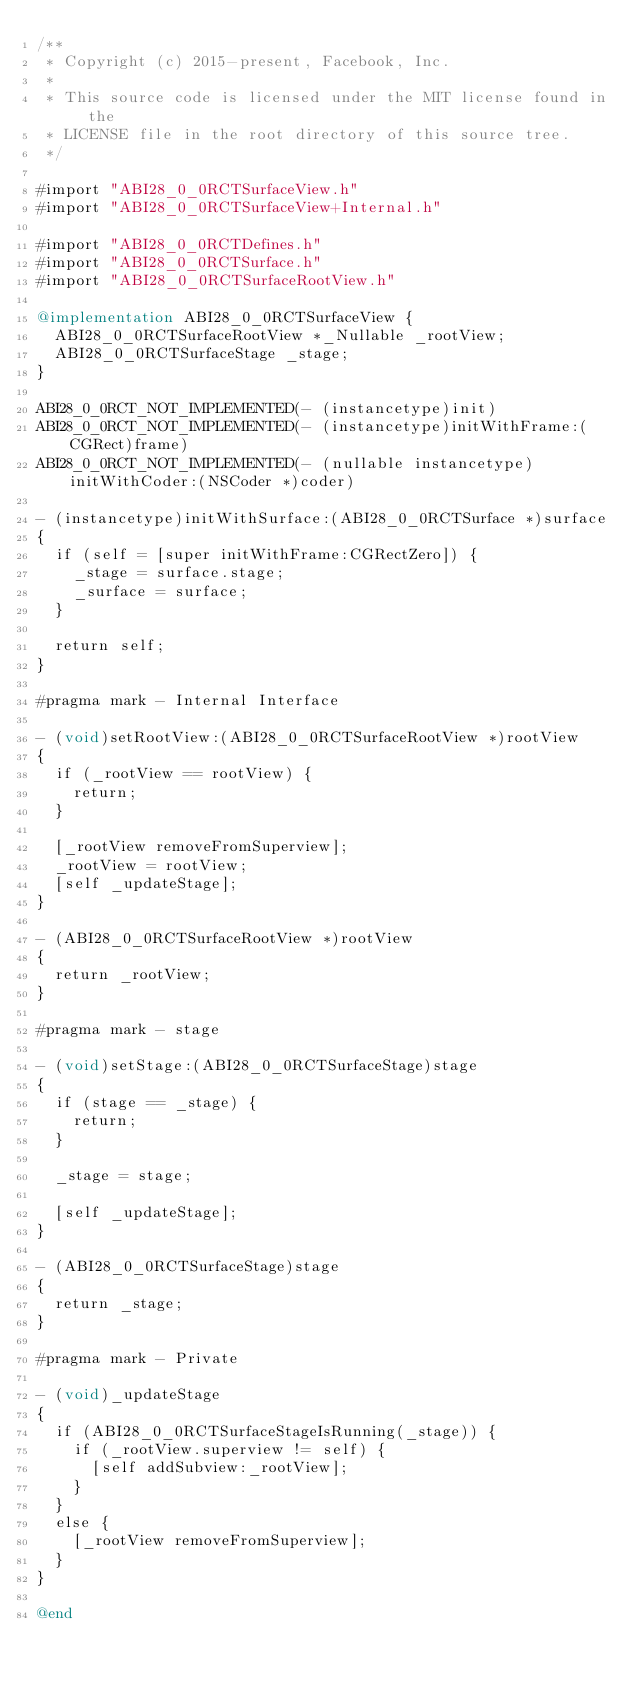Convert code to text. <code><loc_0><loc_0><loc_500><loc_500><_ObjectiveC_>/**
 * Copyright (c) 2015-present, Facebook, Inc.
 *
 * This source code is licensed under the MIT license found in the
 * LICENSE file in the root directory of this source tree.
 */

#import "ABI28_0_0RCTSurfaceView.h"
#import "ABI28_0_0RCTSurfaceView+Internal.h"

#import "ABI28_0_0RCTDefines.h"
#import "ABI28_0_0RCTSurface.h"
#import "ABI28_0_0RCTSurfaceRootView.h"

@implementation ABI28_0_0RCTSurfaceView {
  ABI28_0_0RCTSurfaceRootView *_Nullable _rootView;
  ABI28_0_0RCTSurfaceStage _stage;
}

ABI28_0_0RCT_NOT_IMPLEMENTED(- (instancetype)init)
ABI28_0_0RCT_NOT_IMPLEMENTED(- (instancetype)initWithFrame:(CGRect)frame)
ABI28_0_0RCT_NOT_IMPLEMENTED(- (nullable instancetype)initWithCoder:(NSCoder *)coder)

- (instancetype)initWithSurface:(ABI28_0_0RCTSurface *)surface
{
  if (self = [super initWithFrame:CGRectZero]) {
    _stage = surface.stage;
    _surface = surface;
  }

  return self;
}

#pragma mark - Internal Interface

- (void)setRootView:(ABI28_0_0RCTSurfaceRootView *)rootView
{
  if (_rootView == rootView) {
    return;
  }

  [_rootView removeFromSuperview];
  _rootView = rootView;
  [self _updateStage];
}

- (ABI28_0_0RCTSurfaceRootView *)rootView
{
  return _rootView;
}

#pragma mark - stage

- (void)setStage:(ABI28_0_0RCTSurfaceStage)stage
{
  if (stage == _stage) {
    return;
  }

  _stage = stage;

  [self _updateStage];
}

- (ABI28_0_0RCTSurfaceStage)stage
{
  return _stage;
}

#pragma mark - Private

- (void)_updateStage
{
  if (ABI28_0_0RCTSurfaceStageIsRunning(_stage)) {
    if (_rootView.superview != self) {
      [self addSubview:_rootView];
    }
  }
  else {
    [_rootView removeFromSuperview];
  }
}

@end
</code> 